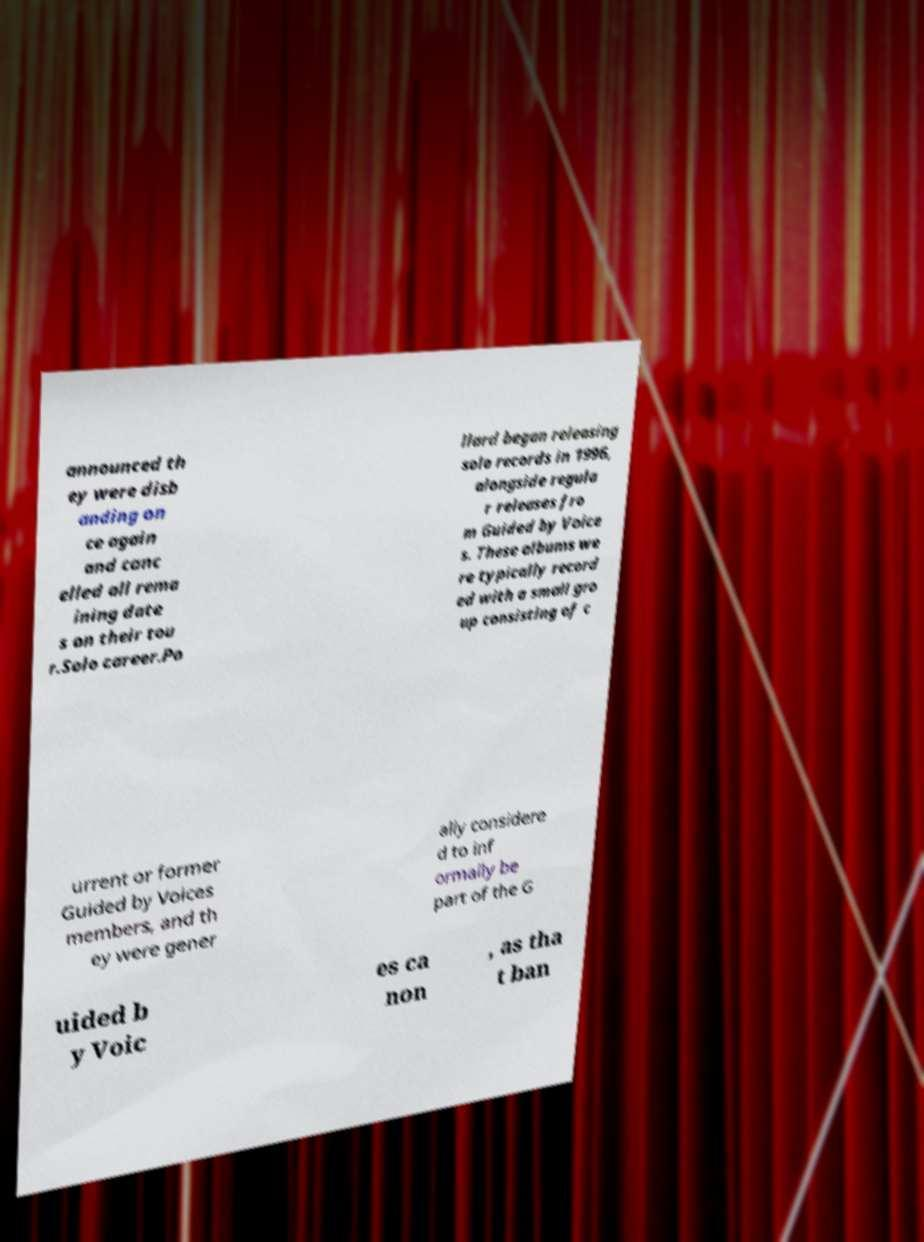There's text embedded in this image that I need extracted. Can you transcribe it verbatim? announced th ey were disb anding on ce again and canc elled all rema ining date s on their tou r.Solo career.Po llard began releasing solo records in 1996, alongside regula r releases fro m Guided by Voice s. These albums we re typically record ed with a small gro up consisting of c urrent or former Guided by Voices members, and th ey were gener ally considere d to inf ormally be part of the G uided b y Voic es ca non , as tha t ban 